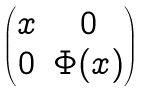<formula> <loc_0><loc_0><loc_500><loc_500>\begin{pmatrix} x & 0 \\ 0 & \Phi ( x ) \end{pmatrix}</formula> 